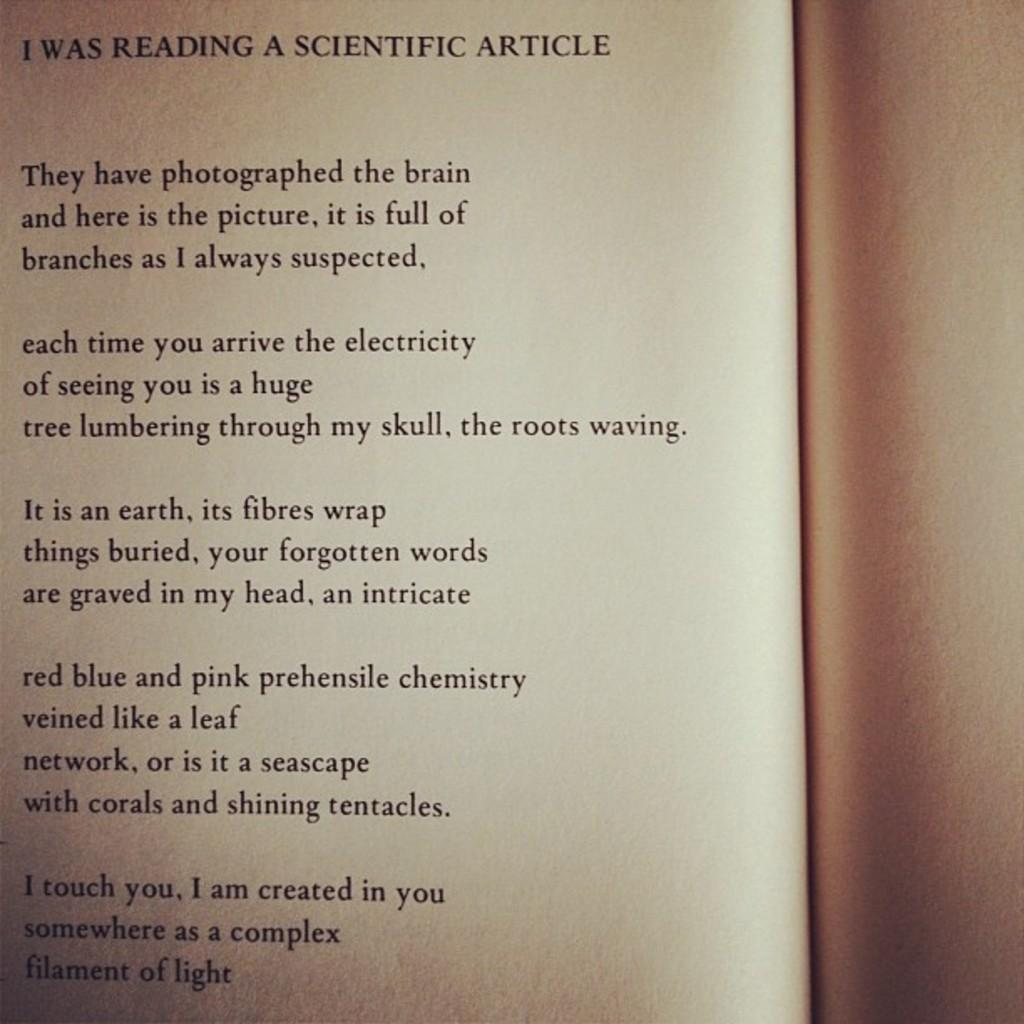<image>
Summarize the visual content of the image. The top of a page says I was reading a scientific article. 